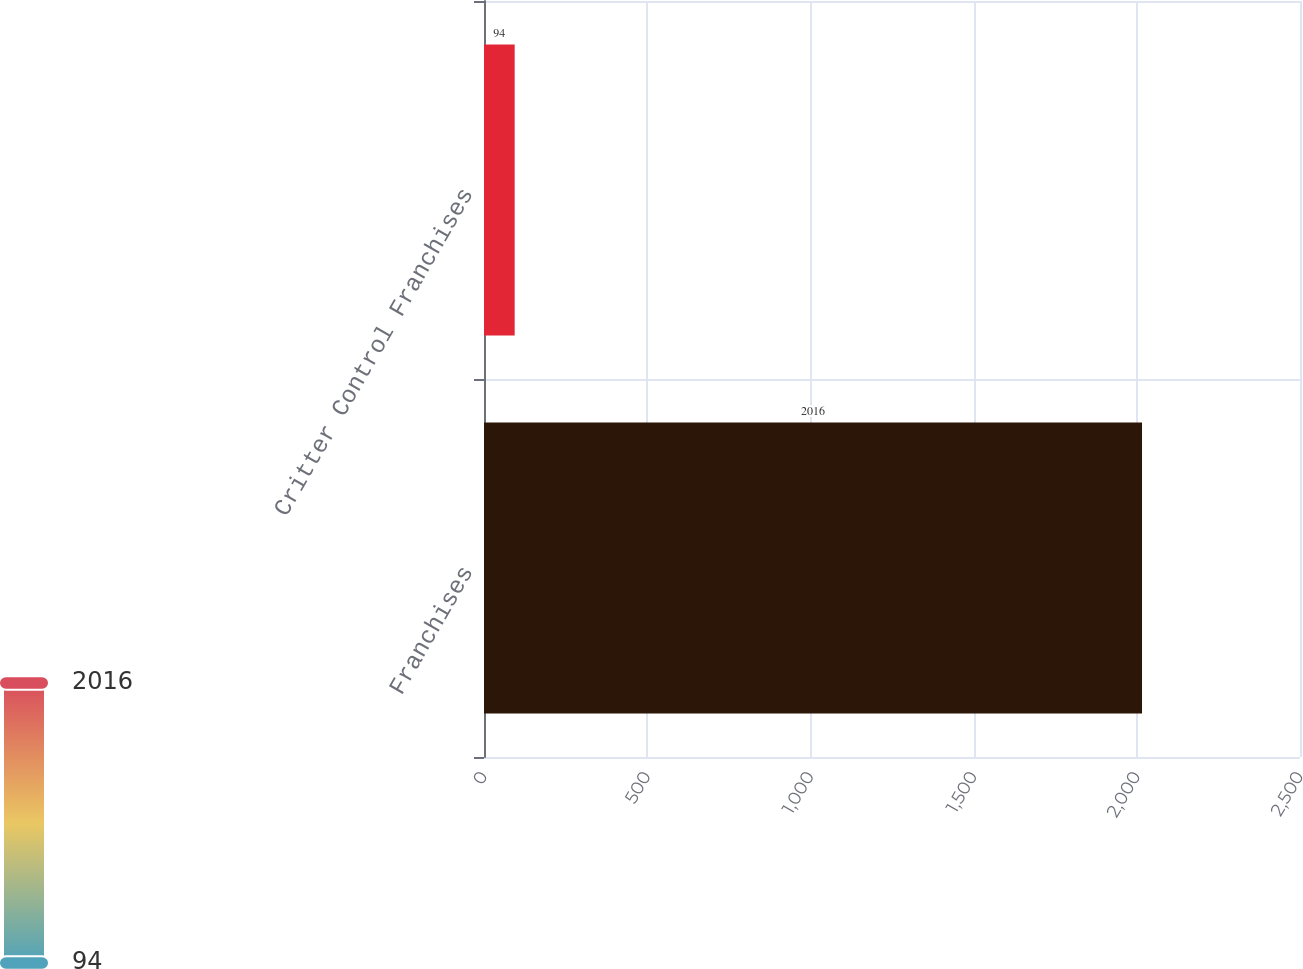<chart> <loc_0><loc_0><loc_500><loc_500><bar_chart><fcel>Franchises<fcel>Critter Control Franchises<nl><fcel>2016<fcel>94<nl></chart> 